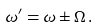<formula> <loc_0><loc_0><loc_500><loc_500>\omega ^ { \prime } = \omega \pm \Omega \, .</formula> 